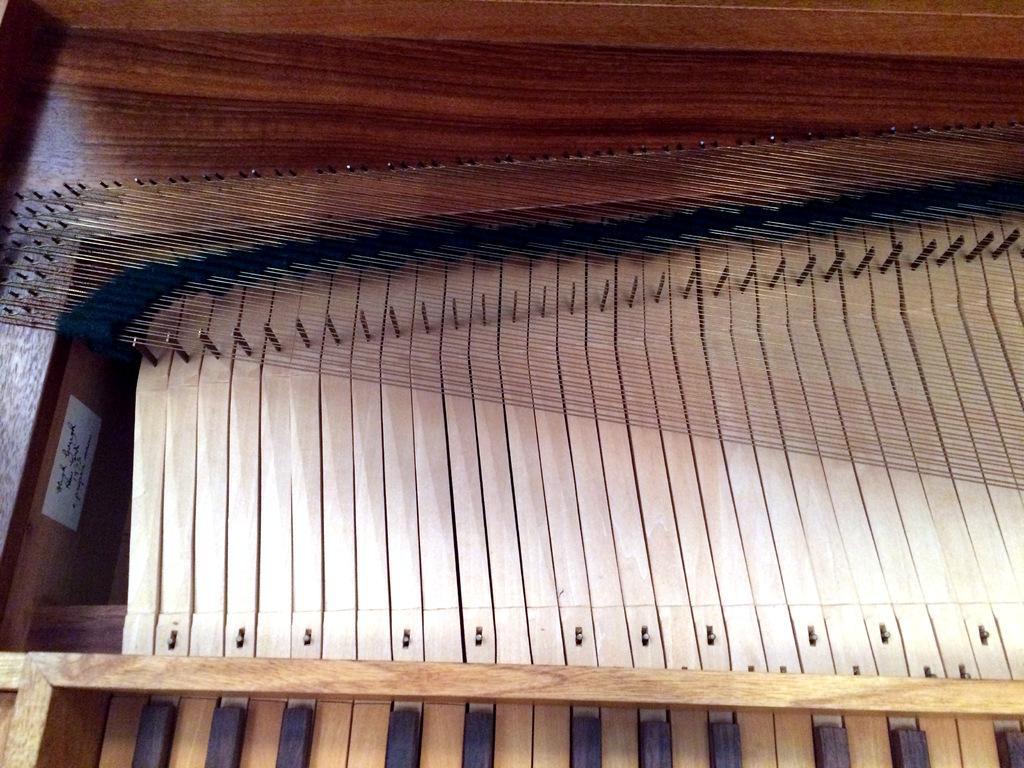Please provide a concise description of this image. In the image we can see this is a musical instrument, made up of wood. 